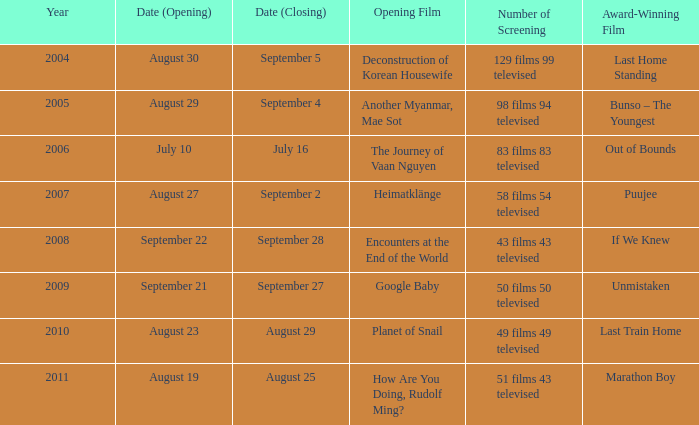Which award-winning film has a screening number of 50 films 50 televised? Unmistaken. 